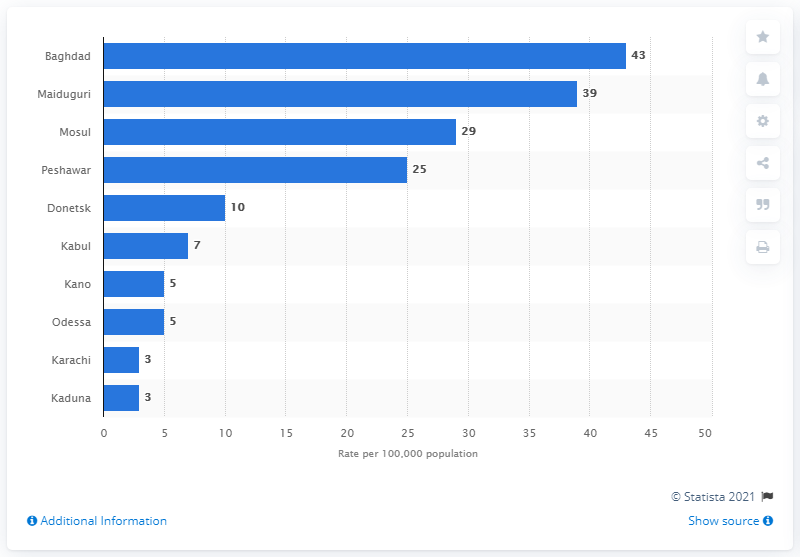Outline some significant characteristics in this image. In 2014, the fatality rate per 100,000 inhabitants in Maiduguri was 39. Maiduguri, a city in Nigeria, had the highest fatality rate from terrorist attacks in 2014. 